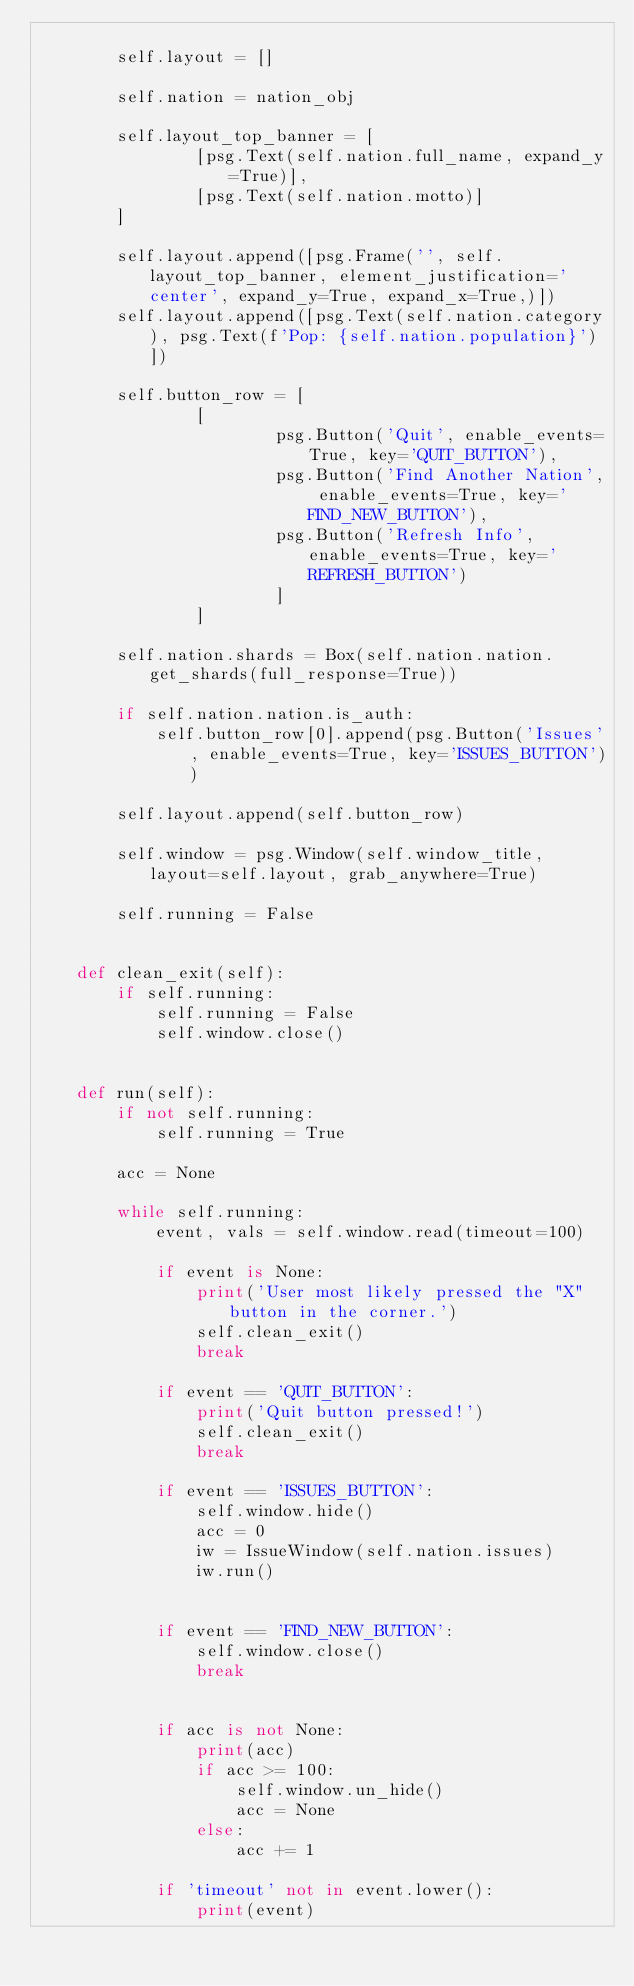<code> <loc_0><loc_0><loc_500><loc_500><_Python_>        
        self.layout = []

        self.nation = nation_obj
        
        self.layout_top_banner = [
                [psg.Text(self.nation.full_name, expand_y=True)],
                [psg.Text(self.nation.motto)]
        ]
        
        self.layout.append([psg.Frame('', self.layout_top_banner, element_justification='center', expand_y=True, expand_x=True,)])
        self.layout.append([psg.Text(self.nation.category), psg.Text(f'Pop: {self.nation.population}')])
        
        self.button_row = [
                [
                        psg.Button('Quit', enable_events=True, key='QUIT_BUTTON'),
                        psg.Button('Find Another Nation', enable_events=True, key='FIND_NEW_BUTTON'),
                        psg.Button('Refresh Info', enable_events=True, key='REFRESH_BUTTON')
                        ]
                ]

        self.nation.shards = Box(self.nation.nation.get_shards(full_response=True))

        if self.nation.nation.is_auth:
            self.button_row[0].append(psg.Button('Issues', enable_events=True, key='ISSUES_BUTTON'))
        
        self.layout.append(self.button_row)
        
        self.window = psg.Window(self.window_title, layout=self.layout, grab_anywhere=True)
        
        self.running = False

        
    def clean_exit(self):
        if self.running:
            self.running = False
            self.window.close()
        
        
    def run(self):
        if not self.running:
            self.running = True
        
        acc = None
        
        while self.running:
            event, vals = self.window.read(timeout=100)
            
            if event is None:
                print('User most likely pressed the "X" button in the corner.')
                self.clean_exit()
                break
                
            if event == 'QUIT_BUTTON':
                print('Quit button pressed!')
                self.clean_exit()
                break
                
            if event == 'ISSUES_BUTTON':
                self.window.hide()
                acc = 0
                iw = IssueWindow(self.nation.issues)
                iw.run()

                
            if event == 'FIND_NEW_BUTTON':
                self.window.close()
                break
                
            
            if acc is not None:
                print(acc)
                if acc >= 100:
                    self.window.un_hide()
                    acc = None
                else:
                    acc += 1
                
            if 'timeout' not in event.lower():
                print(event)
</code> 